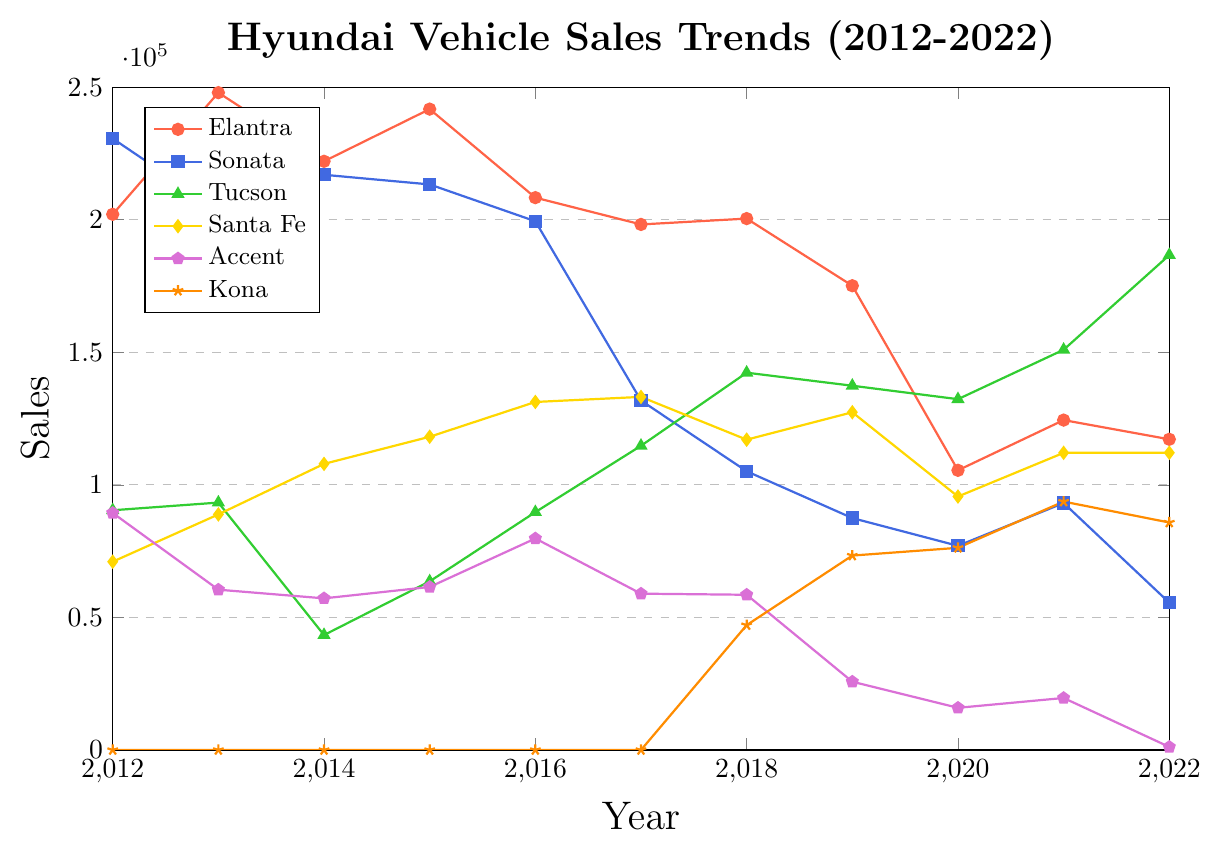What's the trend for Elantra sales from 2012 to 2022? To assess the Elantra trend, observe the line. It starts high in 2012, peaks in 2013, declines gradually with minor fluctuations, and ends lower in 2022.
Answer: Declining Which year did Tucson overtake Santa Fe in sales? Tucson overtook Santa Fe in 2017, as seen where the green line (Tucson) crosses above the yellow line (Santa Fe).
Answer: 2017 What is the cumulative sales of Kona from 2018 to 2022? Add yearly Kona sales from 2018-2022: 47090 + 73326 + 76253 + 93685 + 85795.
Answer: 376149 Which model had the highest increase in sales between 2021 and 2022? Calculate each model's sales difference from 2021 to 2022. Tucson's sales increased significantly from 150949 to 186655, a difference of 35606, the highest among all models.
Answer: Tucson What was the largest sales drop for Accent over the years? From 2019 (25750) to 2022 (1156), Accent dropped by 24594 units, the most significant drop.
Answer: 2019-2022 Compare the sales of Elantra and Sonata in 2020. Which one sold more? In 2020, Elantra sold 105475 units, while Sonata sold 76997. Elantra's sales were higher.
Answer: Elantra Which year did the Hyundai Sonata have the lowest sales? The lowest sales for Sonata occurred in 2022, with only 55555 units sold.
Answer: 2022 What is the average sales of Santa Fe over the decade? Add Santa Fe sales from 2012-2022 and divide by 11. (71016 + 88844 + 107906 + 118134 + 131257 + 133171 + 117038 + 127373 + 95591 + 112071 + 112102) / 11 = 110774
Answer: 110774 In which year did the Accent experience the most significant sales decline? From 2018 (58542) to 2019 (25750), Accent sales dropped the most by 32792 units.
Answer: 2019 If one were to graph the sales trends of all models, which model would visually have the steepest declining trend? Sonata's line declines steeply, especially from 2012 to 2022. This can be seen as the blue line dropping sharply over the years.
Answer: Sonata 